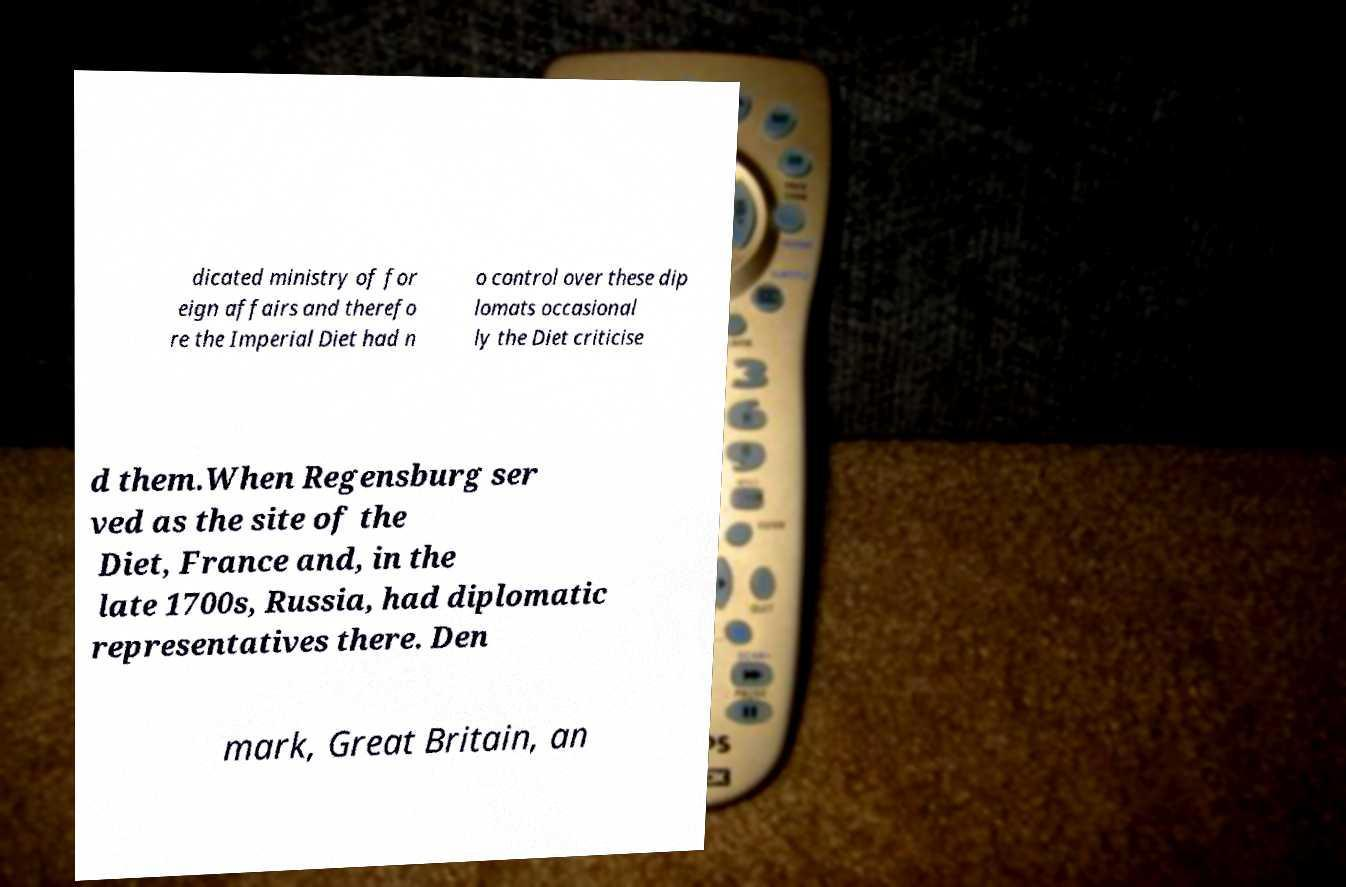Please identify and transcribe the text found in this image. dicated ministry of for eign affairs and therefo re the Imperial Diet had n o control over these dip lomats occasional ly the Diet criticise d them.When Regensburg ser ved as the site of the Diet, France and, in the late 1700s, Russia, had diplomatic representatives there. Den mark, Great Britain, an 